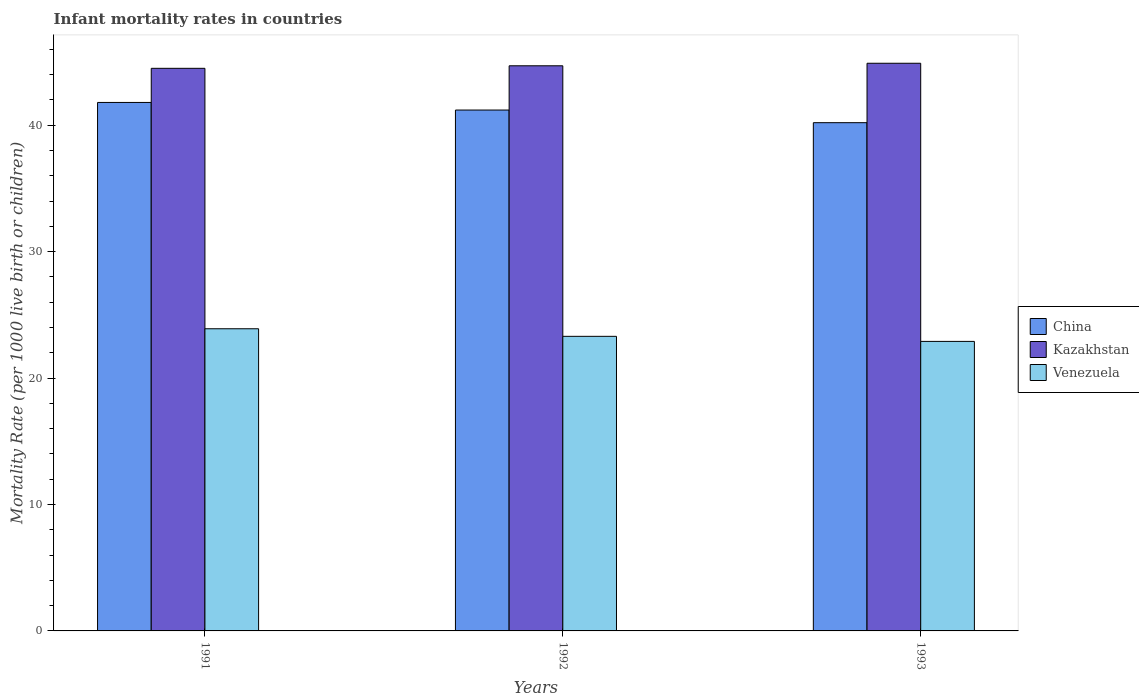How many different coloured bars are there?
Your response must be concise. 3. How many groups of bars are there?
Your answer should be compact. 3. How many bars are there on the 2nd tick from the right?
Your answer should be very brief. 3. What is the infant mortality rate in Kazakhstan in 1993?
Keep it short and to the point. 44.9. Across all years, what is the maximum infant mortality rate in Venezuela?
Make the answer very short. 23.9. Across all years, what is the minimum infant mortality rate in Venezuela?
Offer a very short reply. 22.9. In which year was the infant mortality rate in China maximum?
Your answer should be very brief. 1991. What is the total infant mortality rate in Venezuela in the graph?
Give a very brief answer. 70.1. What is the difference between the infant mortality rate in Kazakhstan in 1992 and the infant mortality rate in Venezuela in 1993?
Provide a succinct answer. 21.8. What is the average infant mortality rate in China per year?
Provide a short and direct response. 41.07. In how many years, is the infant mortality rate in China greater than 12?
Ensure brevity in your answer.  3. What is the ratio of the infant mortality rate in Kazakhstan in 1991 to that in 1993?
Offer a terse response. 0.99. Is the infant mortality rate in Venezuela in 1992 less than that in 1993?
Make the answer very short. No. What is the difference between the highest and the second highest infant mortality rate in China?
Provide a succinct answer. 0.6. What is the difference between the highest and the lowest infant mortality rate in Venezuela?
Your response must be concise. 1. What does the 3rd bar from the left in 1992 represents?
Make the answer very short. Venezuela. What does the 2nd bar from the right in 1993 represents?
Ensure brevity in your answer.  Kazakhstan. Is it the case that in every year, the sum of the infant mortality rate in China and infant mortality rate in Kazakhstan is greater than the infant mortality rate in Venezuela?
Keep it short and to the point. Yes. How many bars are there?
Offer a terse response. 9. Where does the legend appear in the graph?
Your response must be concise. Center right. How many legend labels are there?
Keep it short and to the point. 3. How are the legend labels stacked?
Ensure brevity in your answer.  Vertical. What is the title of the graph?
Keep it short and to the point. Infant mortality rates in countries. Does "Bahamas" appear as one of the legend labels in the graph?
Make the answer very short. No. What is the label or title of the Y-axis?
Ensure brevity in your answer.  Mortality Rate (per 1000 live birth or children). What is the Mortality Rate (per 1000 live birth or children) of China in 1991?
Provide a short and direct response. 41.8. What is the Mortality Rate (per 1000 live birth or children) in Kazakhstan in 1991?
Offer a terse response. 44.5. What is the Mortality Rate (per 1000 live birth or children) in Venezuela in 1991?
Give a very brief answer. 23.9. What is the Mortality Rate (per 1000 live birth or children) of China in 1992?
Your answer should be very brief. 41.2. What is the Mortality Rate (per 1000 live birth or children) in Kazakhstan in 1992?
Ensure brevity in your answer.  44.7. What is the Mortality Rate (per 1000 live birth or children) of Venezuela in 1992?
Provide a short and direct response. 23.3. What is the Mortality Rate (per 1000 live birth or children) of China in 1993?
Provide a short and direct response. 40.2. What is the Mortality Rate (per 1000 live birth or children) in Kazakhstan in 1993?
Give a very brief answer. 44.9. What is the Mortality Rate (per 1000 live birth or children) of Venezuela in 1993?
Give a very brief answer. 22.9. Across all years, what is the maximum Mortality Rate (per 1000 live birth or children) in China?
Ensure brevity in your answer.  41.8. Across all years, what is the maximum Mortality Rate (per 1000 live birth or children) in Kazakhstan?
Give a very brief answer. 44.9. Across all years, what is the maximum Mortality Rate (per 1000 live birth or children) in Venezuela?
Ensure brevity in your answer.  23.9. Across all years, what is the minimum Mortality Rate (per 1000 live birth or children) in China?
Ensure brevity in your answer.  40.2. Across all years, what is the minimum Mortality Rate (per 1000 live birth or children) in Kazakhstan?
Offer a very short reply. 44.5. Across all years, what is the minimum Mortality Rate (per 1000 live birth or children) in Venezuela?
Ensure brevity in your answer.  22.9. What is the total Mortality Rate (per 1000 live birth or children) in China in the graph?
Your response must be concise. 123.2. What is the total Mortality Rate (per 1000 live birth or children) in Kazakhstan in the graph?
Your response must be concise. 134.1. What is the total Mortality Rate (per 1000 live birth or children) of Venezuela in the graph?
Give a very brief answer. 70.1. What is the difference between the Mortality Rate (per 1000 live birth or children) of China in 1991 and that in 1992?
Your answer should be compact. 0.6. What is the difference between the Mortality Rate (per 1000 live birth or children) of Venezuela in 1991 and that in 1992?
Provide a succinct answer. 0.6. What is the difference between the Mortality Rate (per 1000 live birth or children) of Kazakhstan in 1991 and that in 1993?
Provide a short and direct response. -0.4. What is the difference between the Mortality Rate (per 1000 live birth or children) of China in 1992 and that in 1993?
Ensure brevity in your answer.  1. What is the difference between the Mortality Rate (per 1000 live birth or children) in Venezuela in 1992 and that in 1993?
Ensure brevity in your answer.  0.4. What is the difference between the Mortality Rate (per 1000 live birth or children) of China in 1991 and the Mortality Rate (per 1000 live birth or children) of Venezuela in 1992?
Provide a succinct answer. 18.5. What is the difference between the Mortality Rate (per 1000 live birth or children) in Kazakhstan in 1991 and the Mortality Rate (per 1000 live birth or children) in Venezuela in 1992?
Give a very brief answer. 21.2. What is the difference between the Mortality Rate (per 1000 live birth or children) of China in 1991 and the Mortality Rate (per 1000 live birth or children) of Kazakhstan in 1993?
Give a very brief answer. -3.1. What is the difference between the Mortality Rate (per 1000 live birth or children) in Kazakhstan in 1991 and the Mortality Rate (per 1000 live birth or children) in Venezuela in 1993?
Provide a short and direct response. 21.6. What is the difference between the Mortality Rate (per 1000 live birth or children) in China in 1992 and the Mortality Rate (per 1000 live birth or children) in Kazakhstan in 1993?
Give a very brief answer. -3.7. What is the difference between the Mortality Rate (per 1000 live birth or children) in China in 1992 and the Mortality Rate (per 1000 live birth or children) in Venezuela in 1993?
Your response must be concise. 18.3. What is the difference between the Mortality Rate (per 1000 live birth or children) of Kazakhstan in 1992 and the Mortality Rate (per 1000 live birth or children) of Venezuela in 1993?
Offer a very short reply. 21.8. What is the average Mortality Rate (per 1000 live birth or children) of China per year?
Ensure brevity in your answer.  41.07. What is the average Mortality Rate (per 1000 live birth or children) in Kazakhstan per year?
Your response must be concise. 44.7. What is the average Mortality Rate (per 1000 live birth or children) in Venezuela per year?
Ensure brevity in your answer.  23.37. In the year 1991, what is the difference between the Mortality Rate (per 1000 live birth or children) in China and Mortality Rate (per 1000 live birth or children) in Kazakhstan?
Provide a succinct answer. -2.7. In the year 1991, what is the difference between the Mortality Rate (per 1000 live birth or children) of Kazakhstan and Mortality Rate (per 1000 live birth or children) of Venezuela?
Offer a terse response. 20.6. In the year 1992, what is the difference between the Mortality Rate (per 1000 live birth or children) in China and Mortality Rate (per 1000 live birth or children) in Venezuela?
Offer a very short reply. 17.9. In the year 1992, what is the difference between the Mortality Rate (per 1000 live birth or children) in Kazakhstan and Mortality Rate (per 1000 live birth or children) in Venezuela?
Make the answer very short. 21.4. In the year 1993, what is the difference between the Mortality Rate (per 1000 live birth or children) of China and Mortality Rate (per 1000 live birth or children) of Kazakhstan?
Give a very brief answer. -4.7. In the year 1993, what is the difference between the Mortality Rate (per 1000 live birth or children) of China and Mortality Rate (per 1000 live birth or children) of Venezuela?
Provide a short and direct response. 17.3. In the year 1993, what is the difference between the Mortality Rate (per 1000 live birth or children) of Kazakhstan and Mortality Rate (per 1000 live birth or children) of Venezuela?
Keep it short and to the point. 22. What is the ratio of the Mortality Rate (per 1000 live birth or children) in China in 1991 to that in 1992?
Keep it short and to the point. 1.01. What is the ratio of the Mortality Rate (per 1000 live birth or children) in Venezuela in 1991 to that in 1992?
Offer a very short reply. 1.03. What is the ratio of the Mortality Rate (per 1000 live birth or children) of China in 1991 to that in 1993?
Give a very brief answer. 1.04. What is the ratio of the Mortality Rate (per 1000 live birth or children) in Venezuela in 1991 to that in 1993?
Your answer should be compact. 1.04. What is the ratio of the Mortality Rate (per 1000 live birth or children) in China in 1992 to that in 1993?
Provide a succinct answer. 1.02. What is the ratio of the Mortality Rate (per 1000 live birth or children) of Kazakhstan in 1992 to that in 1993?
Keep it short and to the point. 1. What is the ratio of the Mortality Rate (per 1000 live birth or children) in Venezuela in 1992 to that in 1993?
Provide a succinct answer. 1.02. What is the difference between the highest and the second highest Mortality Rate (per 1000 live birth or children) of China?
Make the answer very short. 0.6. What is the difference between the highest and the lowest Mortality Rate (per 1000 live birth or children) of China?
Your answer should be compact. 1.6. 